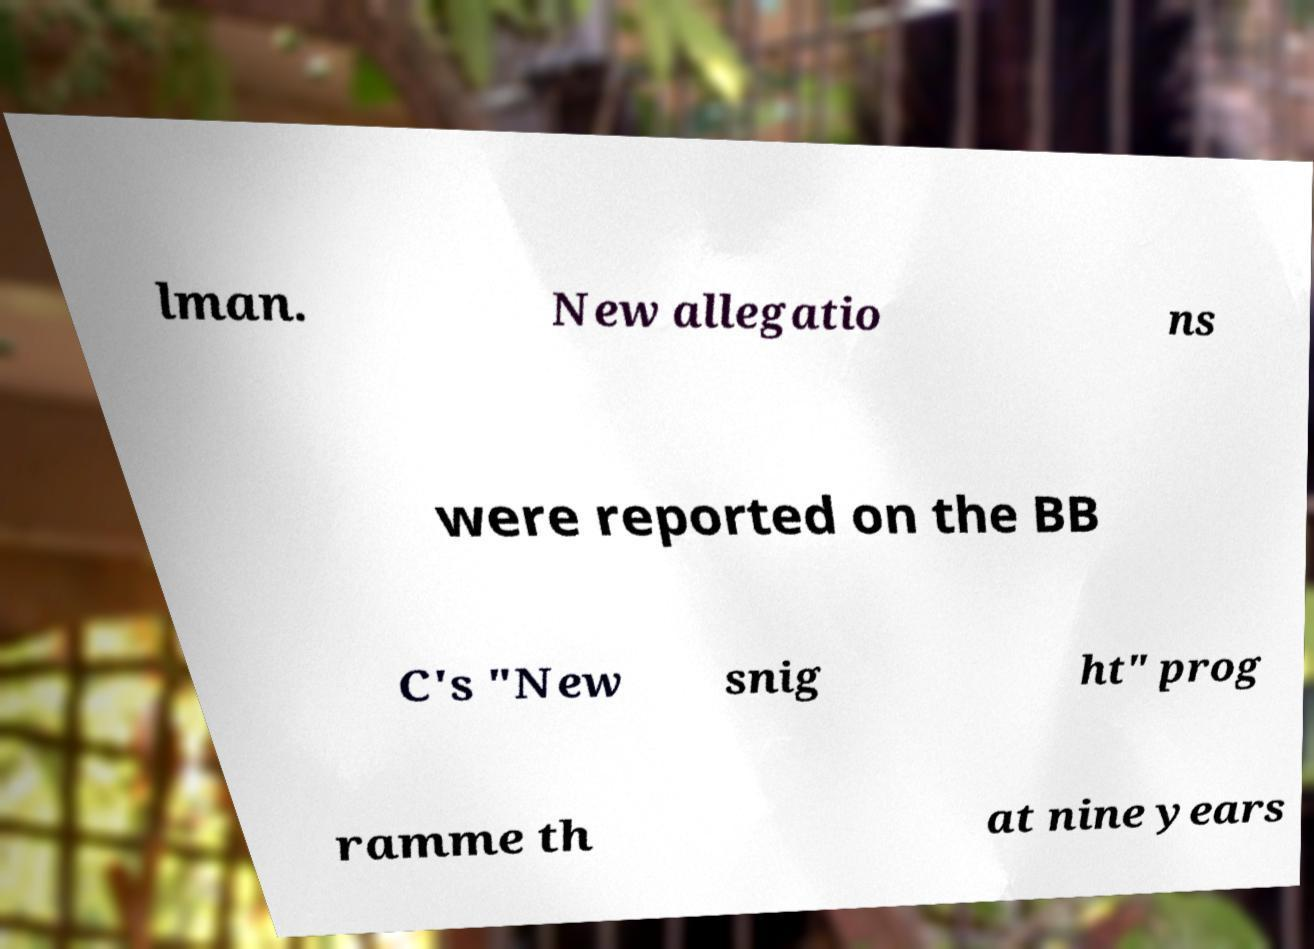What messages or text are displayed in this image? I need them in a readable, typed format. lman. New allegatio ns were reported on the BB C's "New snig ht" prog ramme th at nine years 